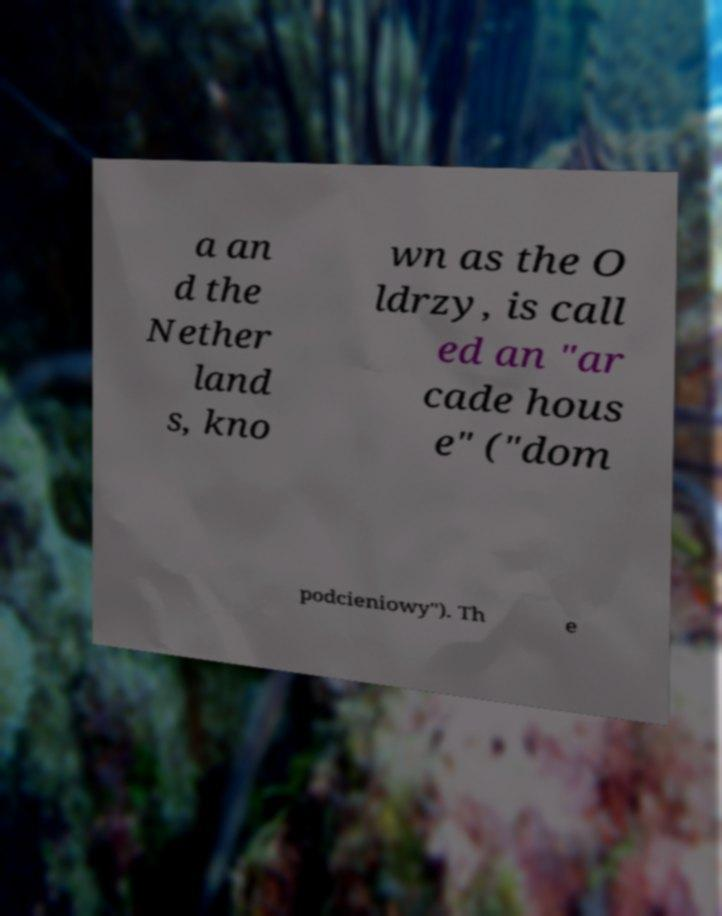Please read and relay the text visible in this image. What does it say? a an d the Nether land s, kno wn as the O ldrzy, is call ed an "ar cade hous e" ("dom podcieniowy"). Th e 